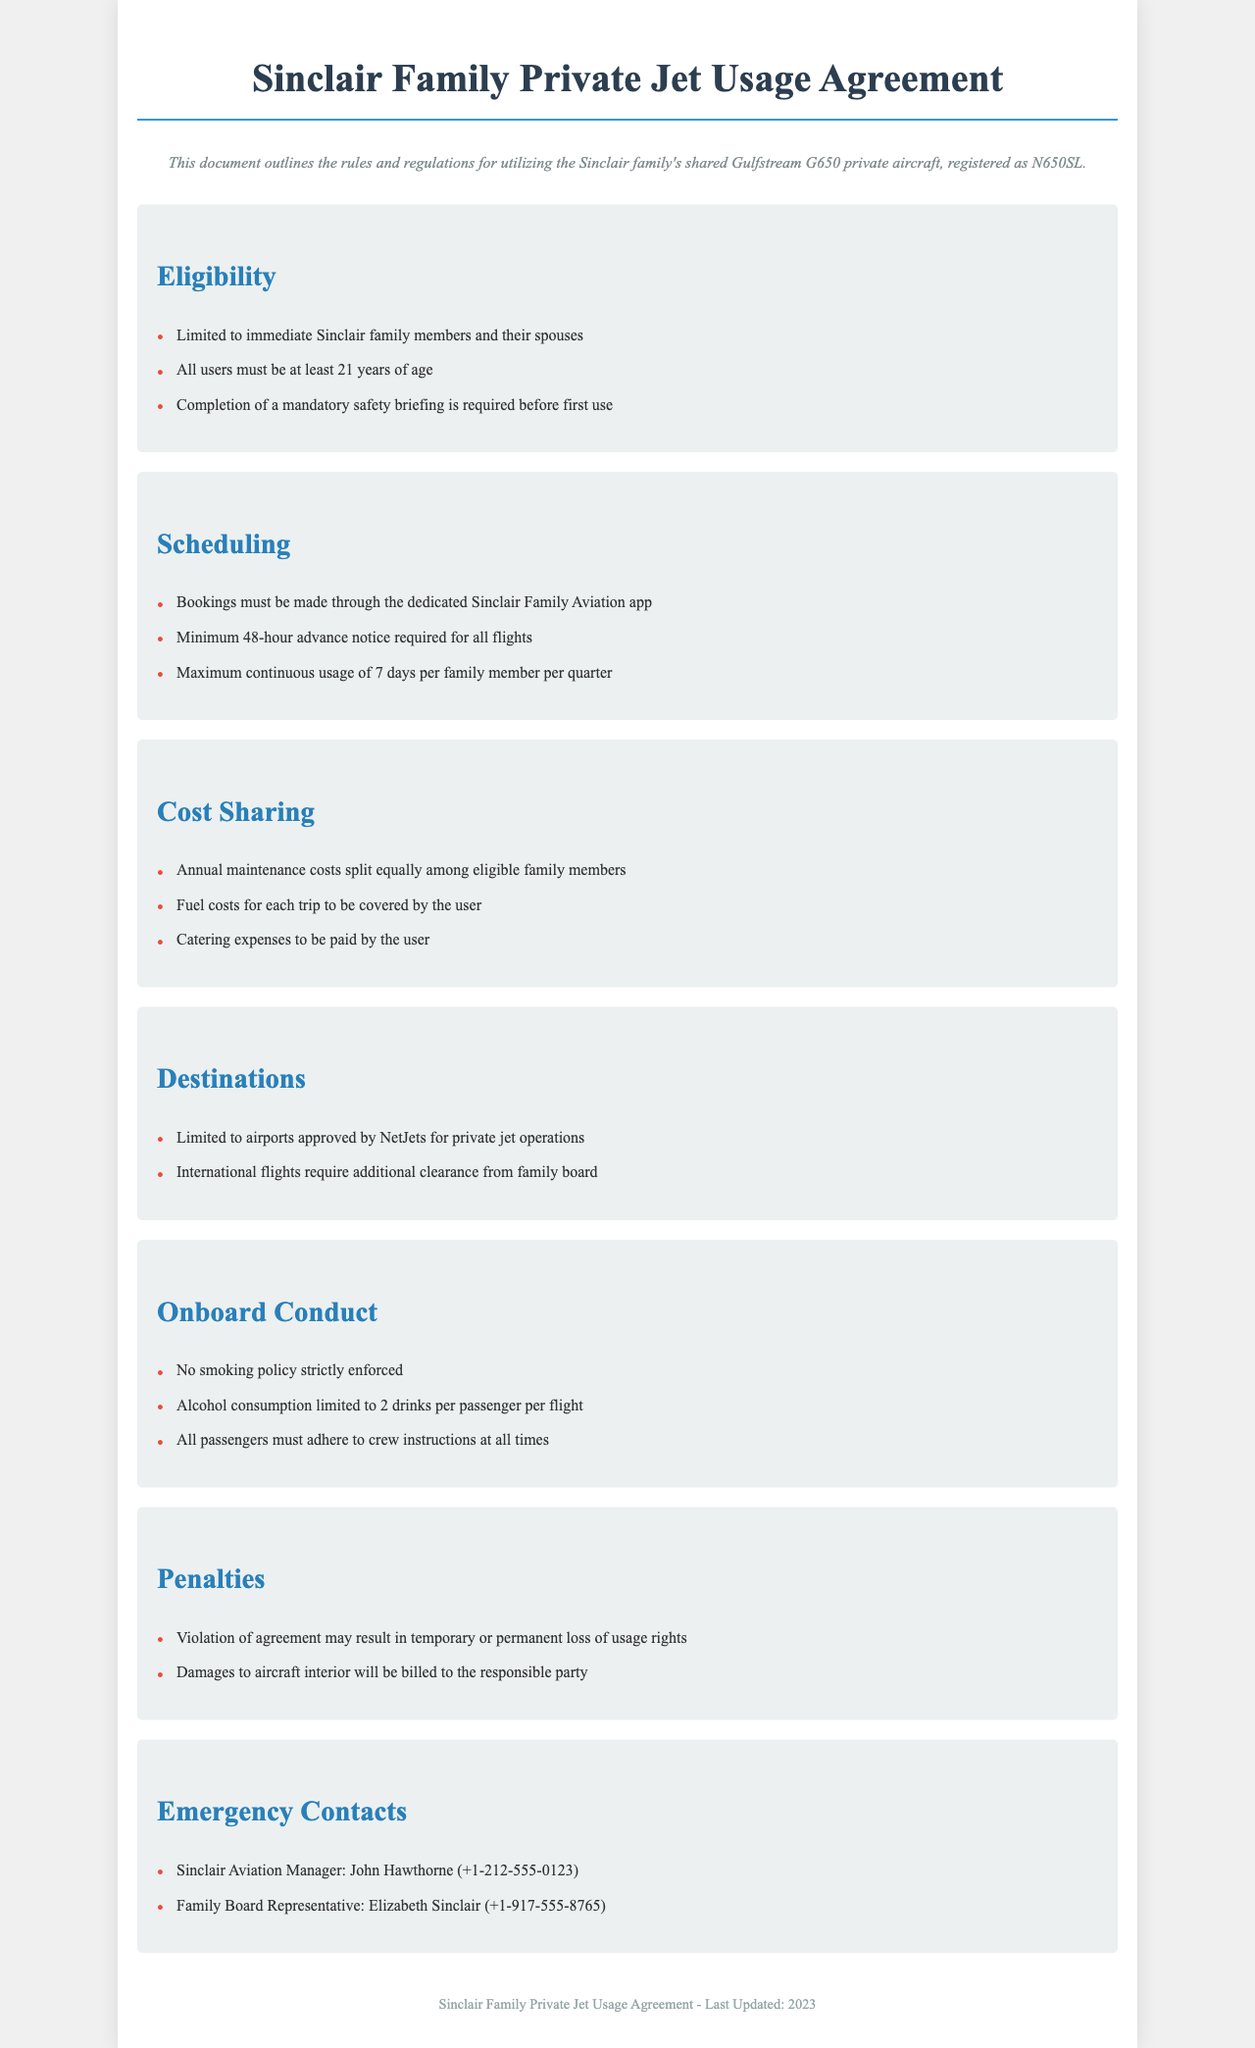What is the name of the aircraft? The aircraft used by the Sinclair family is identified as "Gulfstream G650".
Answer: Gulfstream G650 Who can use the private jet? The document specifies that usage is limited to immediate Sinclair family members and their spouses.
Answer: Immediate Sinclair family members and their spouses What is the maximum continuous usage allowed per family member per quarter? According to the document, the maximum continuous usage is stated as "7 days per family member per quarter".
Answer: 7 days How much advance notice is required for flight bookings? The agreement mentions that a minimum of "48-hour advance notice" is required for all flights.
Answer: 48-hour advance notice What are the fuel costs for each trip classified as? The costs related to fuel for each trip are classified in the document as "to be covered by the user".
Answer: To be covered by the user What is the maximum number of drinks allowed per passenger? The document specifies that alcohol consumption is limited to "2 drinks per passenger per flight".
Answer: 2 drinks What happens if there is damage to the aircraft interior? The agreement states that damages to the aircraft interior will be "billed to the responsible party".
Answer: Billed to the responsible party Who is the Sinclair Aviation Manager? The document lists the Sinclair Aviation Manager as "John Hawthorne".
Answer: John Hawthorne What is a consequence of violating the agreement? The document indicates that a violation may result in "temporary or permanent loss of usage rights".
Answer: Temporary or permanent loss of usage rights 